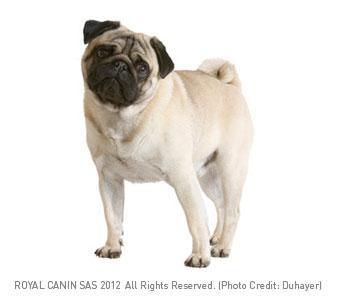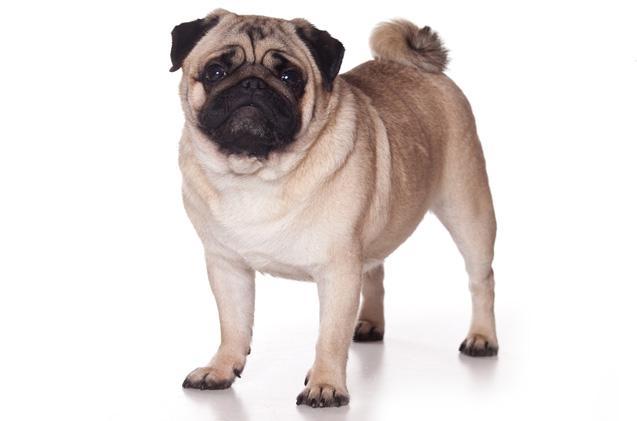The first image is the image on the left, the second image is the image on the right. Given the left and right images, does the statement "In one of the images, a dog is sitting down" hold true? Answer yes or no. No. 